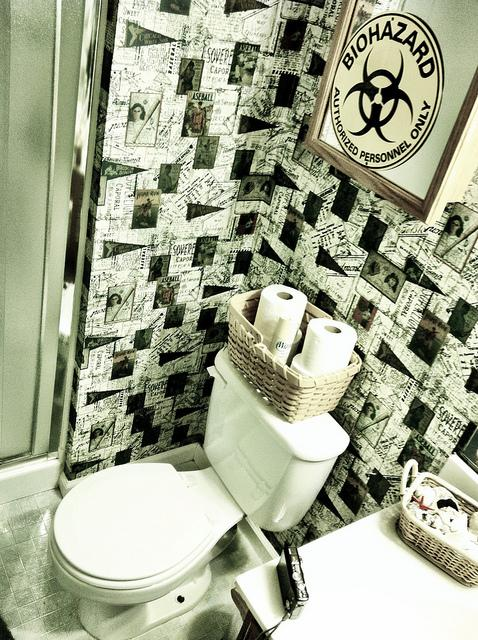What does the sign say? biohazard 